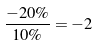<formula> <loc_0><loc_0><loc_500><loc_500>\frac { - 2 0 \% } { 1 0 \% } = - 2</formula> 